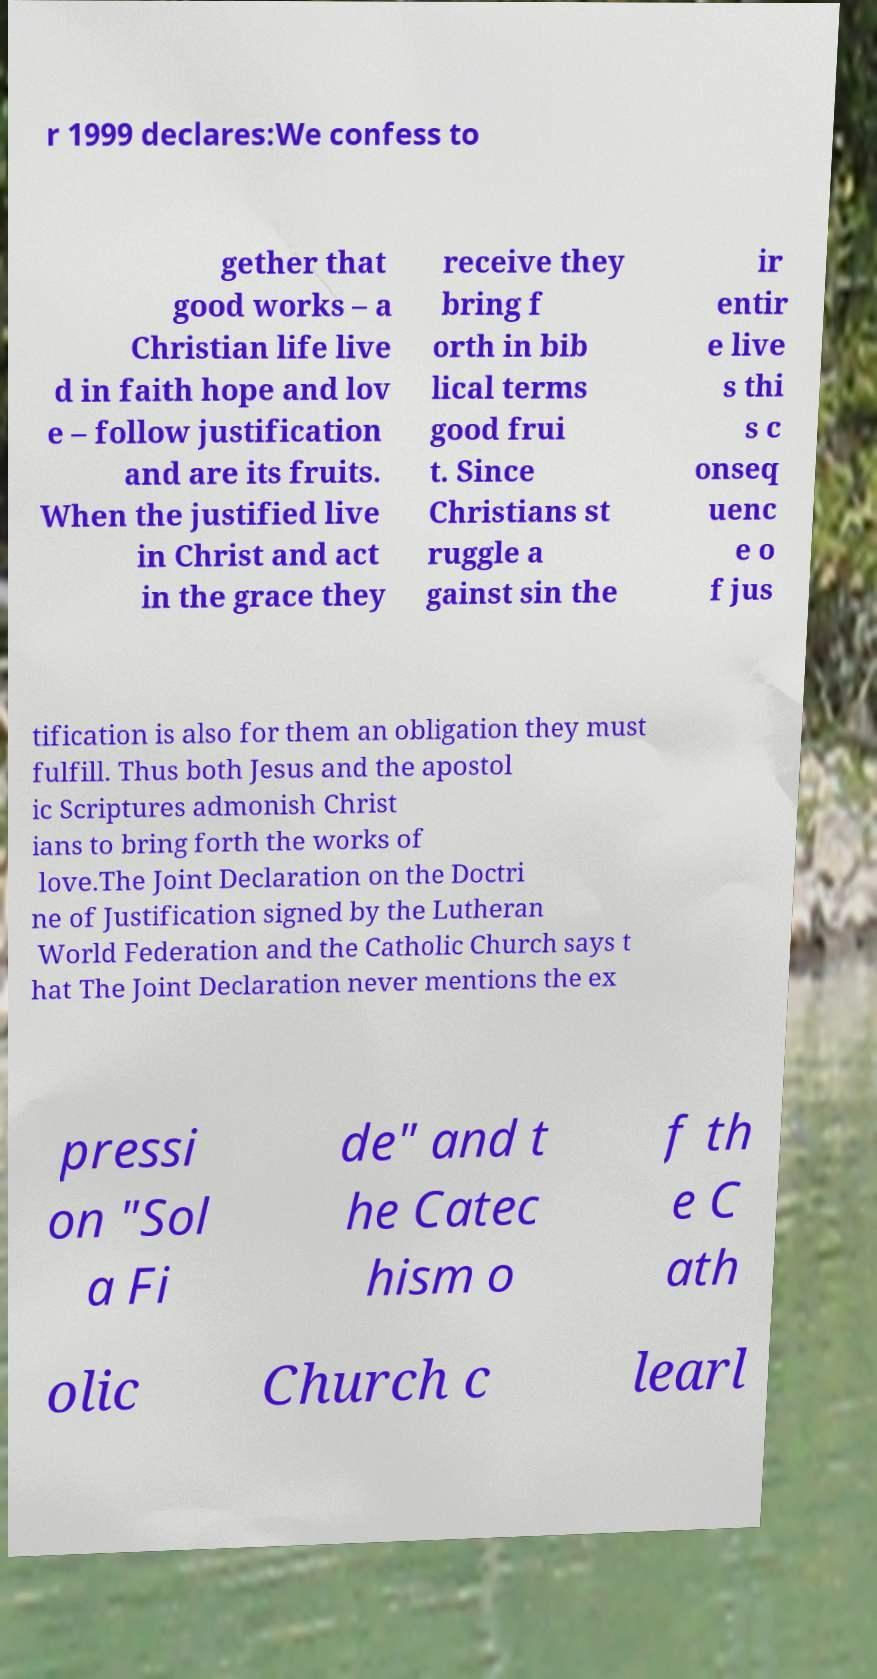What messages or text are displayed in this image? I need them in a readable, typed format. r 1999 declares:We confess to gether that good works – a Christian life live d in faith hope and lov e – follow justification and are its fruits. When the justified live in Christ and act in the grace they receive they bring f orth in bib lical terms good frui t. Since Christians st ruggle a gainst sin the ir entir e live s thi s c onseq uenc e o f jus tification is also for them an obligation they must fulfill. Thus both Jesus and the apostol ic Scriptures admonish Christ ians to bring forth the works of love.The Joint Declaration on the Doctri ne of Justification signed by the Lutheran World Federation and the Catholic Church says t hat The Joint Declaration never mentions the ex pressi on "Sol a Fi de" and t he Catec hism o f th e C ath olic Church c learl 